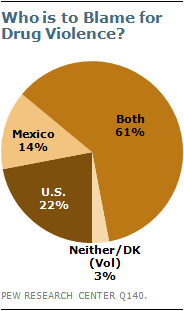List a handful of essential elements in this visual. The name of the biggest segment is both... Please provide the total value of the biggest and smallest segments, rounded to four decimal places, as follows: 64.000000. 